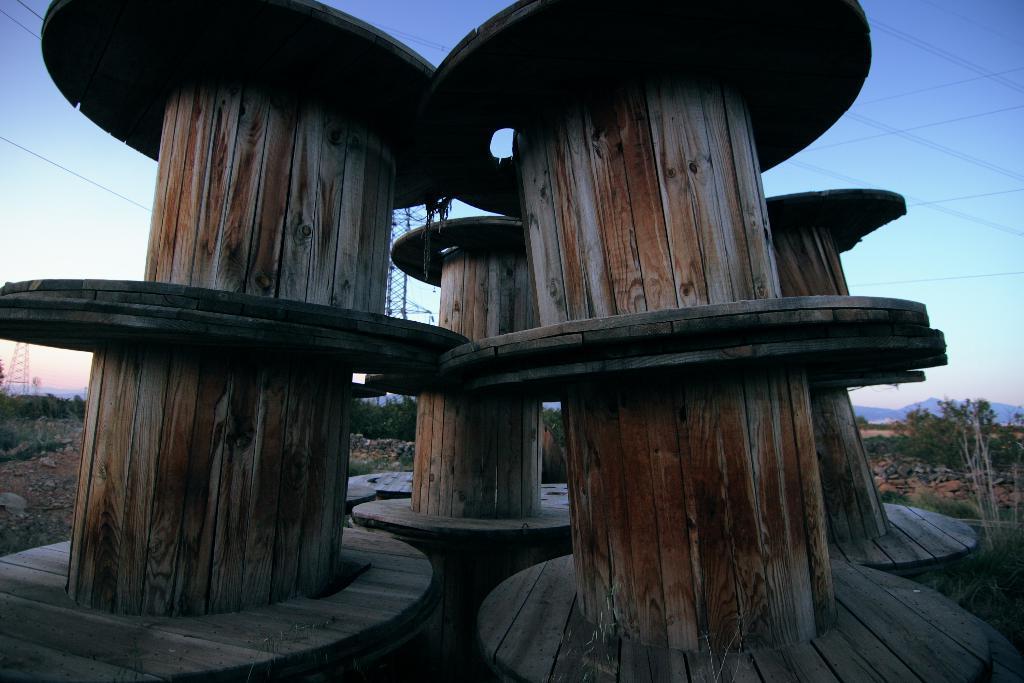Could you give a brief overview of what you see in this image? In this picture we can see few wooden roles, in the background we can find few trees and towers. 